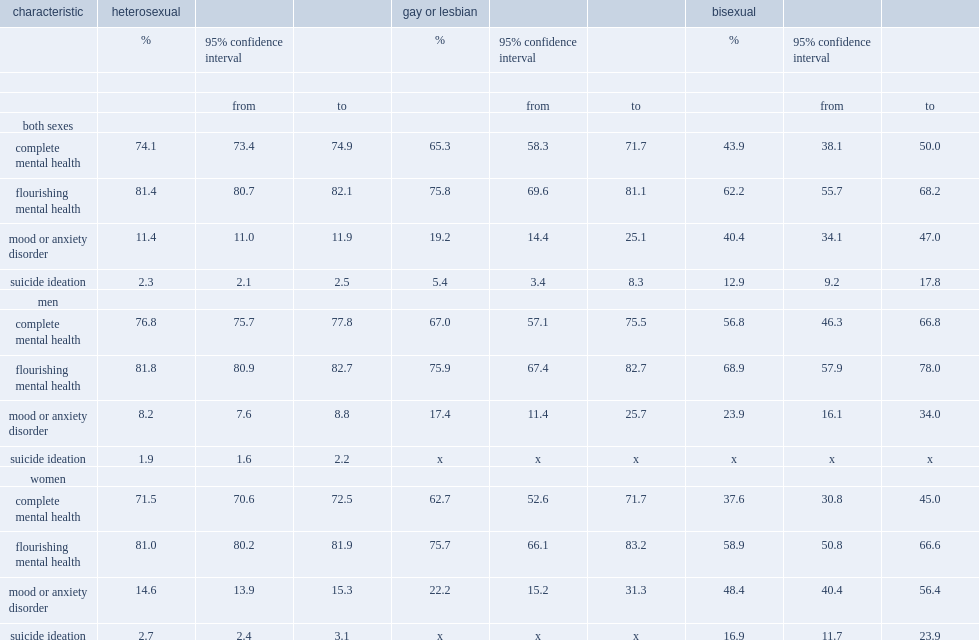Which characteristic is the least likely to be diagnosed with a mood or anxiety disorder, heterosexual, bisexual or gay or lesbian individuals when both sexes are combined? Heterosexual. Which characteristic is the least likely to experience suicide ideation in the previous 12 months, heterosexual, bisexual or gay or lesbian individuals when both sexes are combined? Heterosexual. Which characteristic is less likely to be in flourishing mental health, heterosexual or bisexual individuals when both sexes are combined? Bisexual. Which characteristic is the most likely to have complete mental health, heterosexual, bisexual or gay or lesbian individuals when both sexes are combined? Heterosexual. 